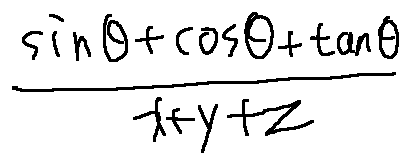Convert formula to latex. <formula><loc_0><loc_0><loc_500><loc_500>\frac { \sin \theta + \cos \theta + \tan \theta } { x + y + z }</formula> 